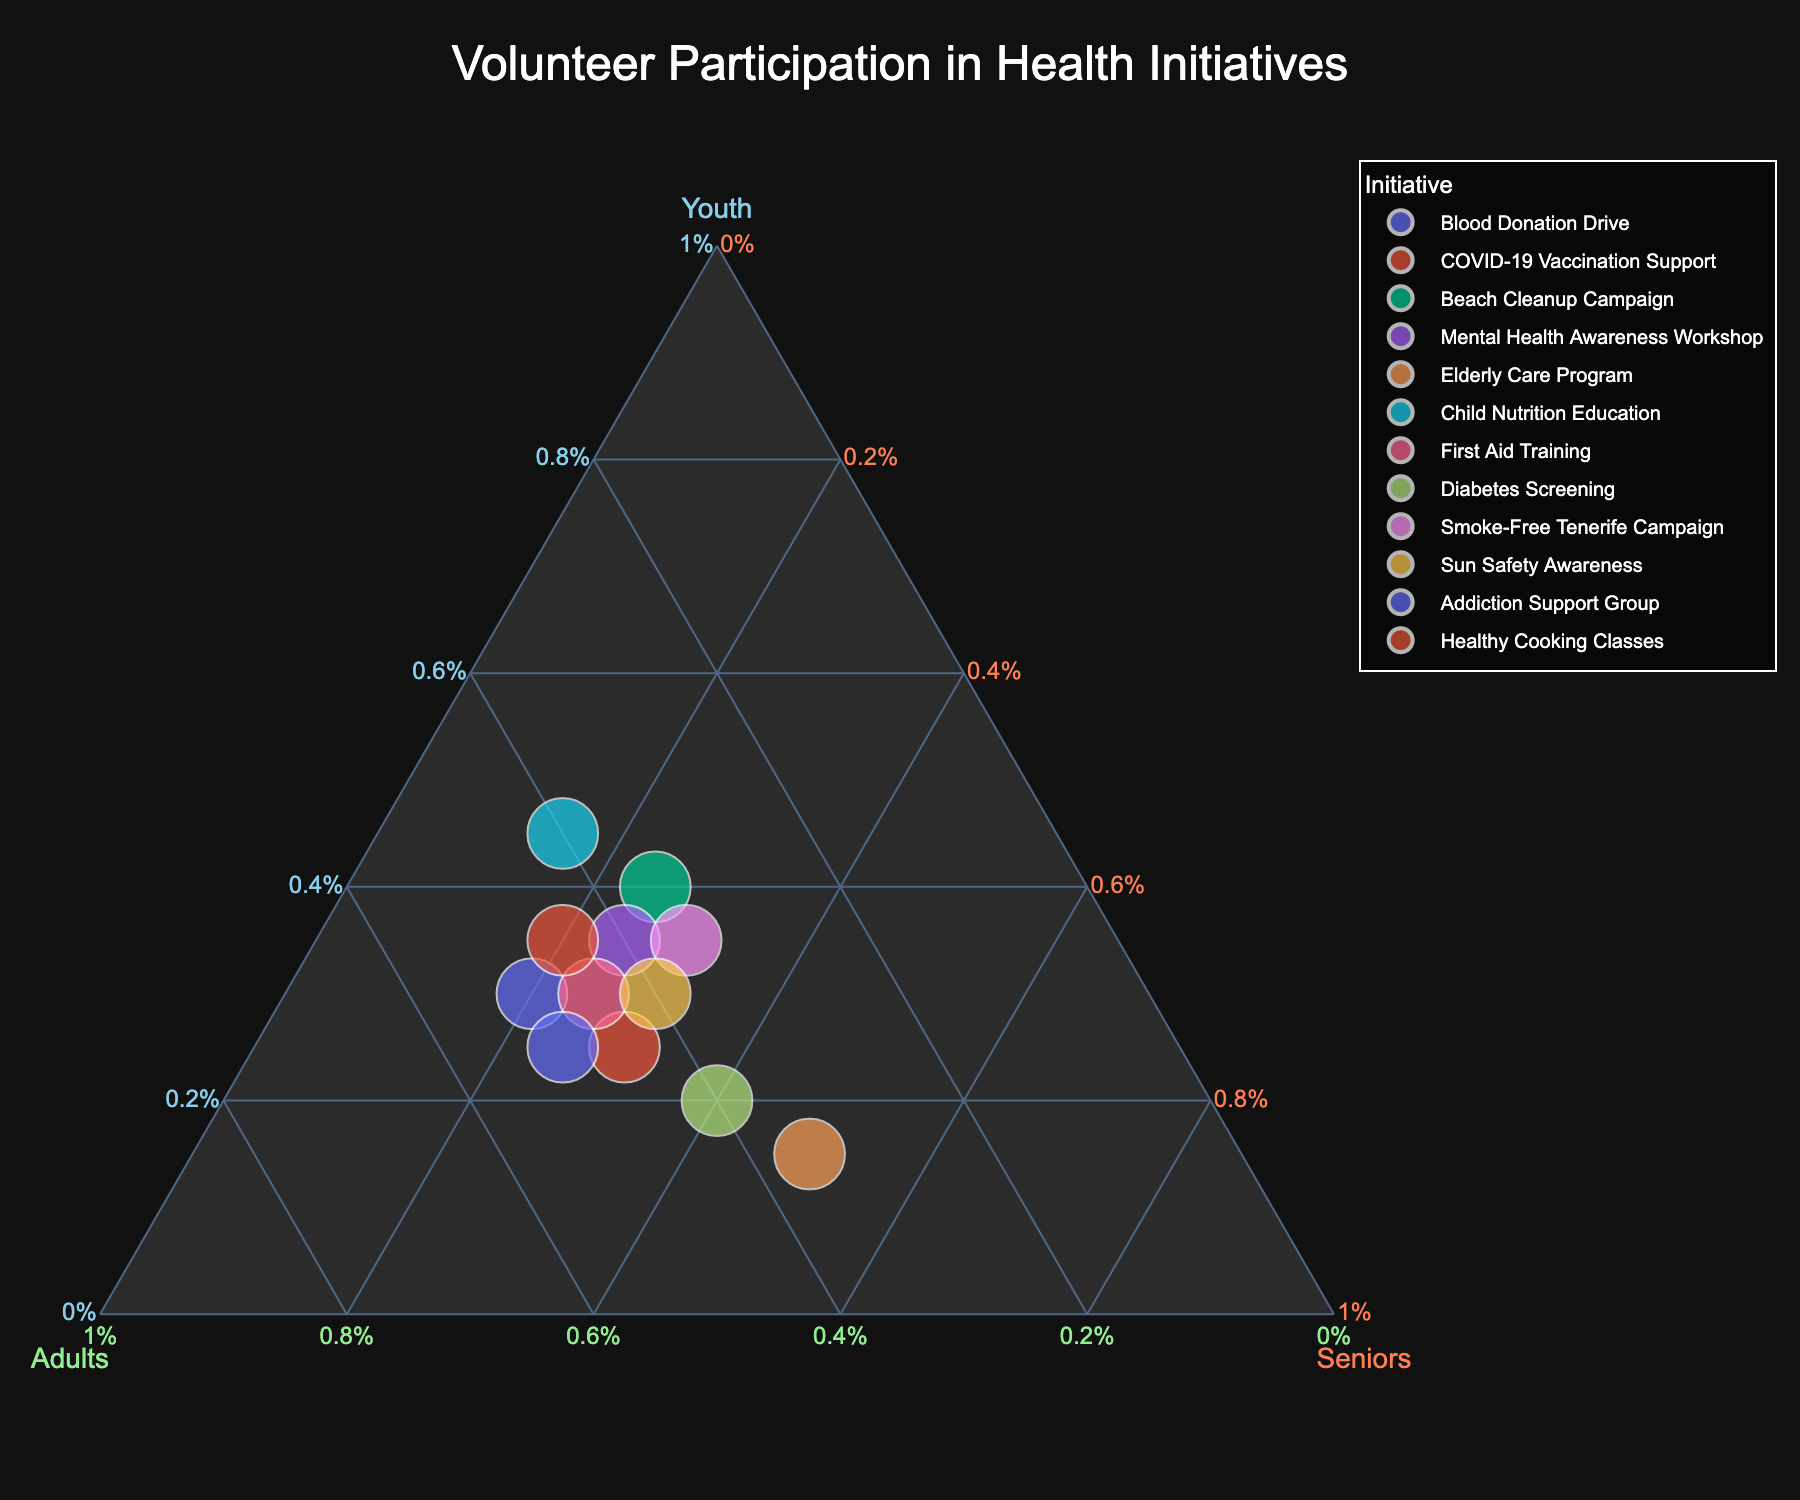What's the title of the figure? The title is displayed prominently at the top of the figure in large font.
Answer: Volunteer Participation in Health Initiatives How many initiatives are presented in the figure? Each point on the ternary plot represents a different initiative, and hovering over the points will reveal their names. By counting the number of data points or initiatives, you can determine the total.
Answer: 12 Which axis corresponds to the Seniors participation percentage? The titles of the axes are clearly labeled with their respective age groups, and the Seniors participation percentage is labeled along the c-axis.
Answer: c-axis Which health initiative has the highest percentage of Youth participation? Hover over each point to view the participation percentages for each initiative. Identify the initiative with the highest Youth percentage.
Answer: Child Nutrition Education Which initiative has the most balanced participation among Youth, Adults, and Seniors? By observing the position of the points within the ternary plot, the initiative closest to the center will have the most balanced participation.
Answer: Sun Safety Awareness Which health initiative has the highest total number of volunteers? The size of the points represents the total number of participants. The initiative with the largest point size has the highest number of total volunteers.
Answer: Blood Donation Drive How does the Youth participation in the Smoke-Free Tenerife Campaign compare to the Adults' participation in the same campaign? By hovering over the point for the Smoke-Free Tenerife Campaign, the Youth and Adults participation percentages can be compared directly.
Answer: Equal, both are 35% What is the combined percentage of Adults and Seniors participation in the Elderly Care Program? Add the percentage of Adults and Seniors participation together. The percentages can be found by hovering over the point for the Elderly Care Program.
Answer: 85% (Adults: 35%, Seniors: 50%) Which initiative shows a higher percentage of participation from Seniors than Youth? By hovering over each point, compare the percentages of Seniors and Youth. Identify which initiatives have a higher percentage for Seniors than Youth.
Answer: Elderly Care Program, Diabetes Screening In the COVID-19 Vaccination Support initiative, how much higher is the Seniors participation percentage compared to Youth? Subtract the Youth participation percentage from the Seniors percentage. Hover over the point for the COVID-19 Vaccination Support to get the percentages.
Answer: 5% higher (Seniors: 30%, Youth: 25%) 